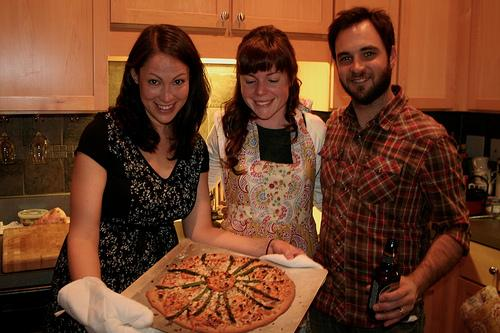How are the people feeling while holding the food? Please explain your reasoning. proud. They are showing off what they made. 